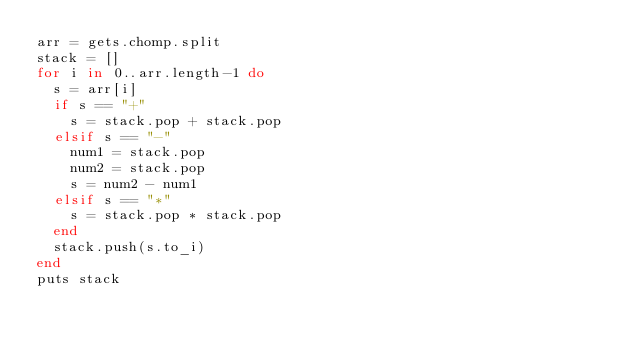Convert code to text. <code><loc_0><loc_0><loc_500><loc_500><_Ruby_>arr = gets.chomp.split
stack = []
for i in 0..arr.length-1 do
  s = arr[i]
  if s == "+"
    s = stack.pop + stack.pop
  elsif s == "-"
    num1 = stack.pop
    num2 = stack.pop
    s = num2 - num1
  elsif s == "*"
    s = stack.pop * stack.pop
  end
  stack.push(s.to_i)
end
puts stack
</code> 